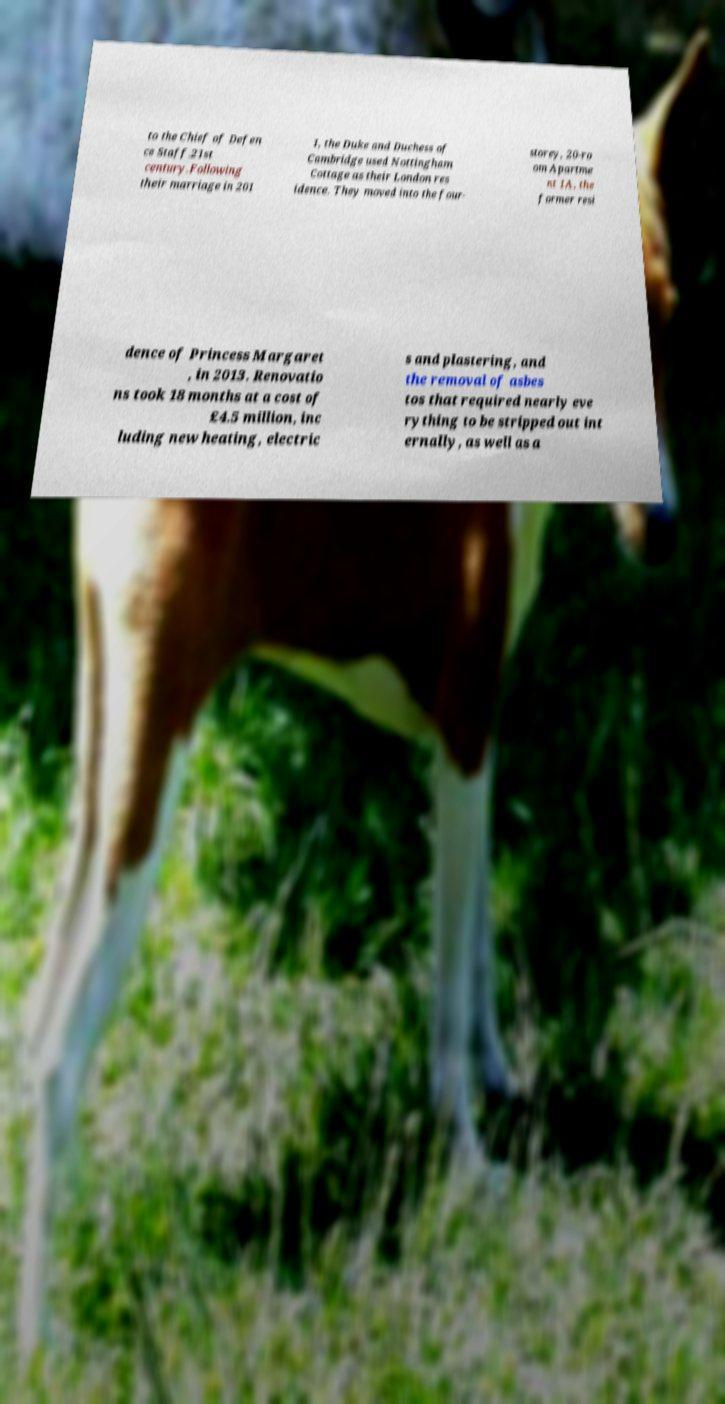Could you assist in decoding the text presented in this image and type it out clearly? to the Chief of Defen ce Staff.21st century.Following their marriage in 201 1, the Duke and Duchess of Cambridge used Nottingham Cottage as their London res idence. They moved into the four- storey, 20-ro om Apartme nt 1A, the former resi dence of Princess Margaret , in 2013. Renovatio ns took 18 months at a cost of £4.5 million, inc luding new heating, electric s and plastering, and the removal of asbes tos that required nearly eve rything to be stripped out int ernally, as well as a 